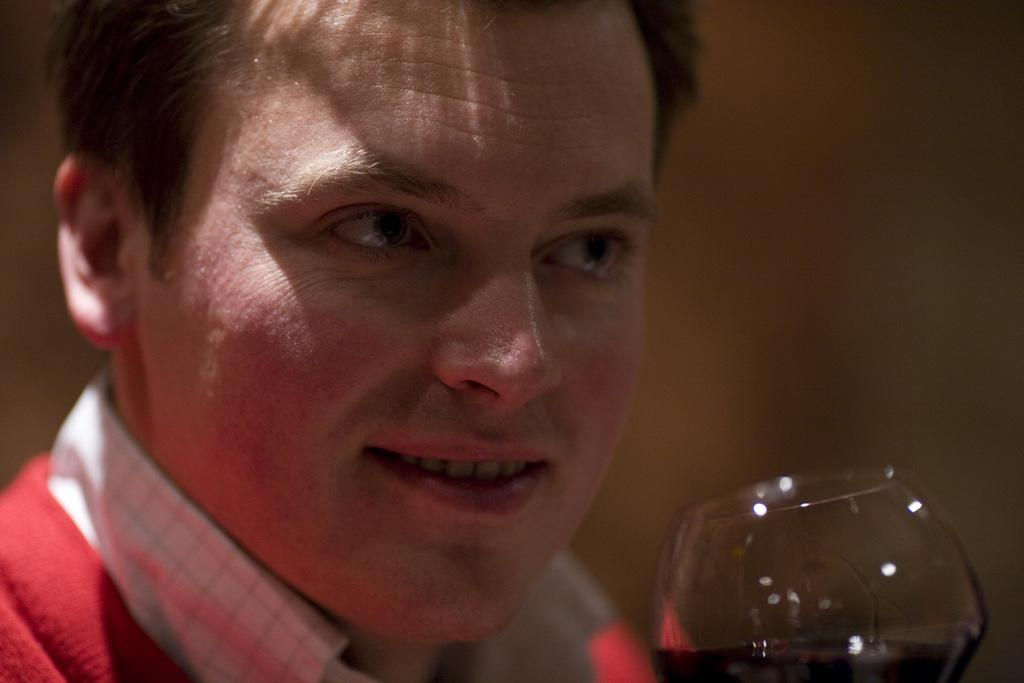Who is the main subject in the image? There is a man in the center of the image. What object is located at the bottom side of the image? There is a glass at the bottom side of the image. What grade did the man receive for his recent haircut in the image? There is no mention of a haircut or grade in the image, so we cannot answer that question. 